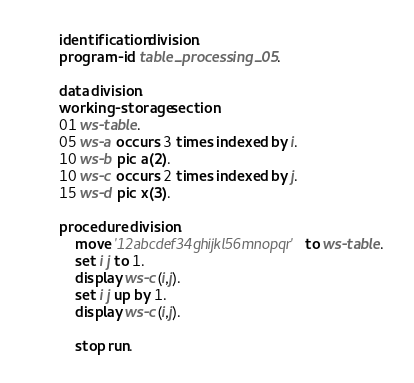<code> <loc_0><loc_0><loc_500><loc_500><_COBOL_>       identification division.
       program-id. table_processing_05.

       data division.
       working-storage section.
       01 ws-table.
       05 ws-a occurs 3 times indexed by i.
       10 ws-b pic a(2).
       10 ws-c occurs 2 times indexed by j.
       15 ws-d pic x(3).

       procedure division.
           move '12abcdef34ghijkl56mnopqr' to ws-table.
           set i j to 1.
           display ws-c(i,j).
           set i j up by 1.
           display ws-c(i,j).

           stop run.
</code> 